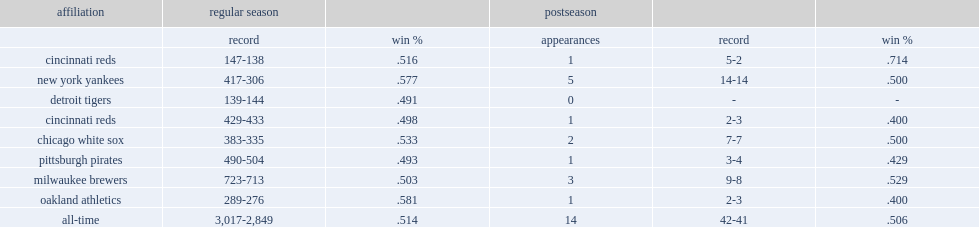What was oakland athletics's record in the regular season? 289-276. 